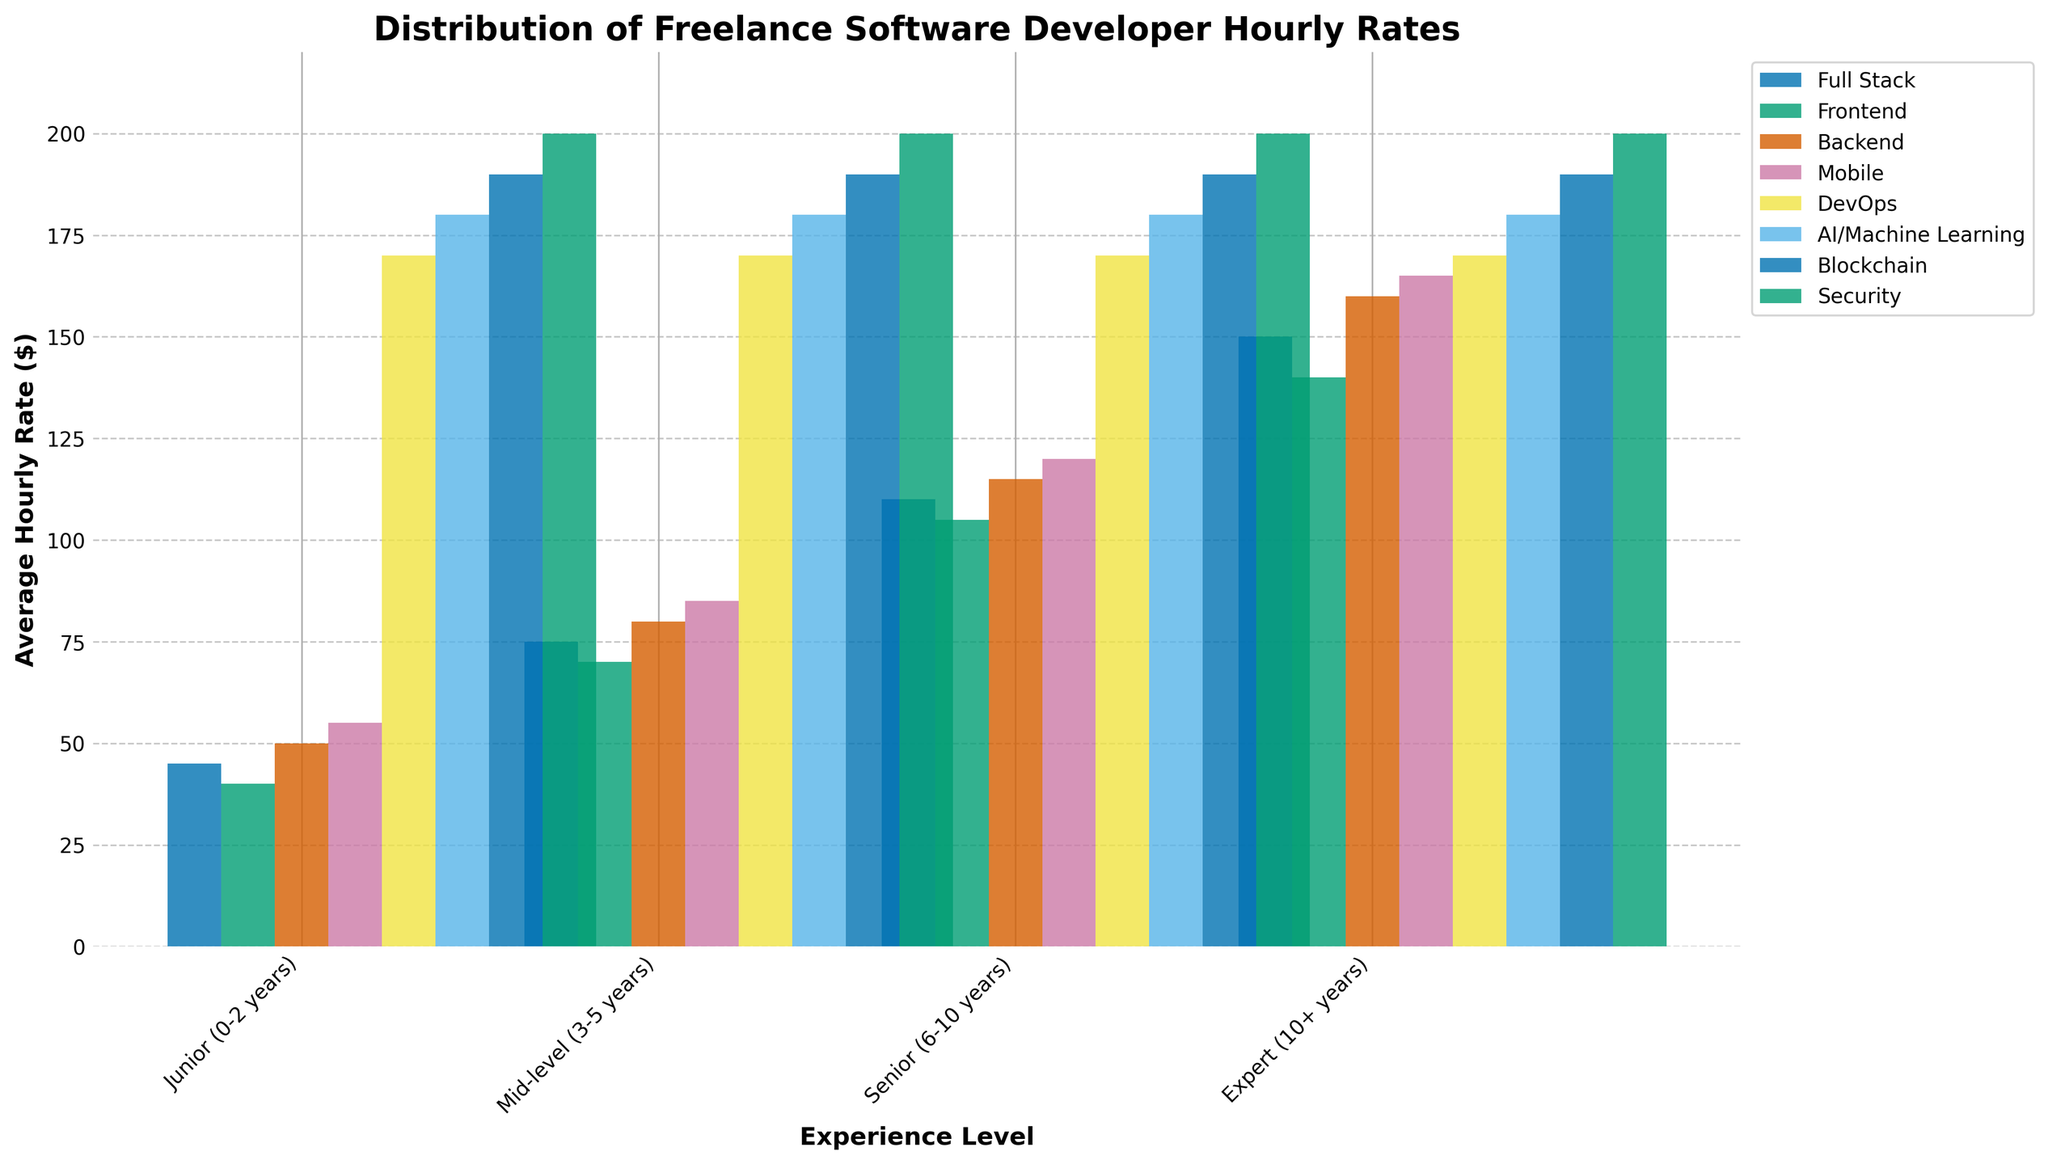How does the hourly rate vary for junior developers across different specializations? Look at the "Junior (0-2 years)" category and observe the height of the bars for different specializations. Full Stack: $45, Frontend: $40, Backend: $50, Mobile: $55. Mobile is the highest and Frontend is the lowest.
Answer: Full Stack: $45, Frontend: $40, Backend: $50, Mobile: $55 Which specialization has the highest average hourly rate for expert developers? Look at the "Expert (10+ years)" category and find the tallest bar. Security has the highest bar.
Answer: Security What is the total average hourly rate for mid-level developers across all specializations? Sum up the average rates for "Mid-level (3-5 years)" category: Full Stack: $75, Frontend: $70, Backend: $80, Mobile: $85. $75 + $70 + $80 + $85 = $310.
Answer: $310 How does the average hourly rate for senior backend developers compare with that of senior frontend developers? Look at the "Senior (6-10 years)" category and compare the height of the Backend and Frontend bars. Backend: $115, Frontend: $105. Backend is $10 higher than Frontend.
Answer: Backend is $10 higher Which specialization shows the greatest increase in hourly rate from junior to mid-level positions? Compare the rate increase for specializations from "Junior (0-2 years)" to "Mid-level (3-5 years)" categories: Full Stack: $75 - $45 = $30, Frontend: $70 - $40 = $30, Backend: $80 - $50 = $30, Mobile: $85 - $55 = $30. All have the same increase of $30.
Answer: All increase by $30 Among expert developers, which specialization has the second-highest hourly rate? Look at the "Expert (10+ years)" category and find the second tallest bar. Blockchain has the second tallest bar after Security.
Answer: Blockchain What is the range of hourly rates for mid-level developers across all specializations? Identify the lowest and highest rates in "Mid-level (3-5 years)" category: Lowest: Frontend ($70), Highest: Mobile ($85). Range: $85 - $70 = $15.
Answer: $15 Compare the average hourly rates for mid-level full stack developers and expert full stack developers. By how much do they differ? Look at "Mid-level (3-5 years)" category for Full Stack ($75) and "Expert (10+ years)" category for Full Stack ($150). $150 - $75 = $75.
Answer: $75 